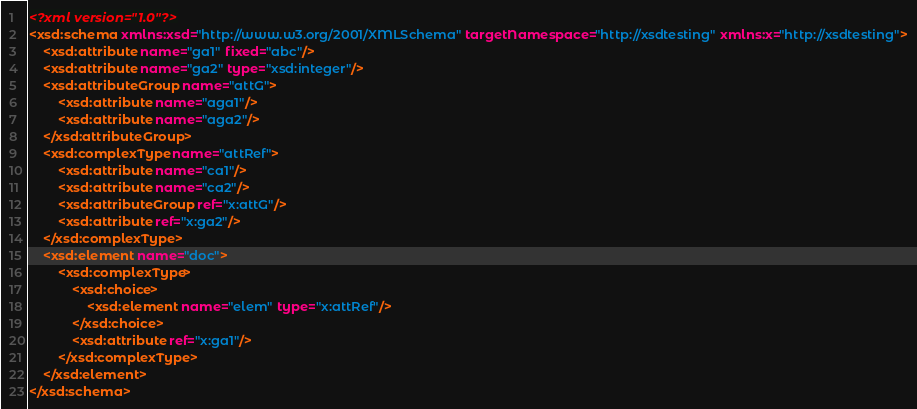<code> <loc_0><loc_0><loc_500><loc_500><_XML_><?xml version="1.0"?>
<xsd:schema xmlns:xsd="http://www.w3.org/2001/XMLSchema" targetNamespace="http://xsdtesting" xmlns:x="http://xsdtesting">
	<xsd:attribute name="ga1" fixed="abc"/>
	<xsd:attribute name="ga2" type="xsd:integer"/>
	<xsd:attributeGroup name="attG">
		<xsd:attribute name="aga1"/>
		<xsd:attribute name="aga2"/>
	</xsd:attributeGroup>
	<xsd:complexType name="attRef">
		<xsd:attribute name="ca1"/>
		<xsd:attribute name="ca2"/>
		<xsd:attributeGroup ref="x:attG"/>
		<xsd:attribute ref="x:ga2"/>
	</xsd:complexType>
	<xsd:element name="doc">
		<xsd:complexType>
			<xsd:choice>
				<xsd:element name="elem" type="x:attRef"/>
			</xsd:choice>
			<xsd:attribute ref="x:ga1"/>
		</xsd:complexType>
	</xsd:element>
</xsd:schema>
</code> 